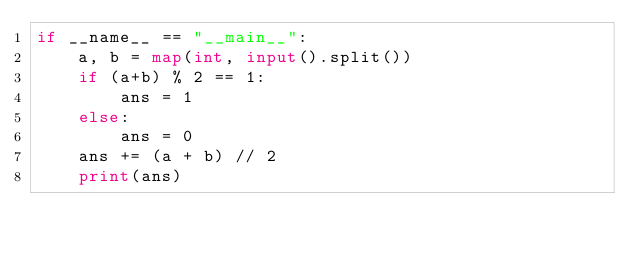Convert code to text. <code><loc_0><loc_0><loc_500><loc_500><_Python_>if __name__ == "__main__":
    a, b = map(int, input().split())
    if (a+b) % 2 == 1:
        ans = 1
    else:
        ans = 0
    ans += (a + b) // 2
    print(ans)
</code> 